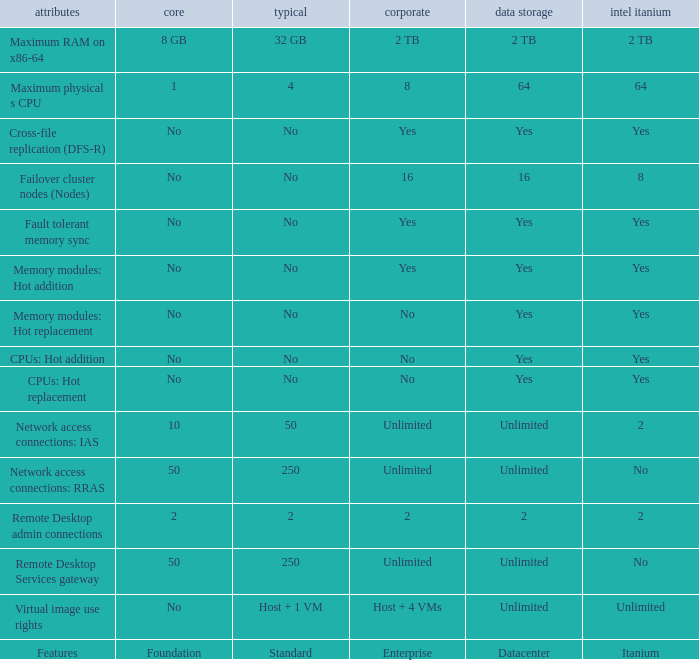What is the Datacenter for the Fault Tolerant Memory Sync Feature that has Yes for Itanium and No for Standard? Yes. 